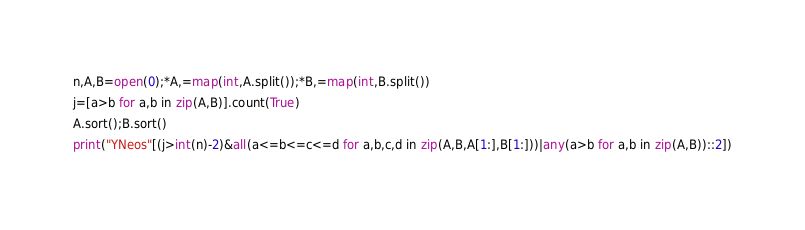Convert code to text. <code><loc_0><loc_0><loc_500><loc_500><_Python_>n,A,B=open(0);*A,=map(int,A.split());*B,=map(int,B.split())
j=[a>b for a,b in zip(A,B)].count(True)
A.sort();B.sort()
print("YNeos"[(j>int(n)-2)&all(a<=b<=c<=d for a,b,c,d in zip(A,B,A[1:],B[1:]))|any(a>b for a,b in zip(A,B))::2])</code> 